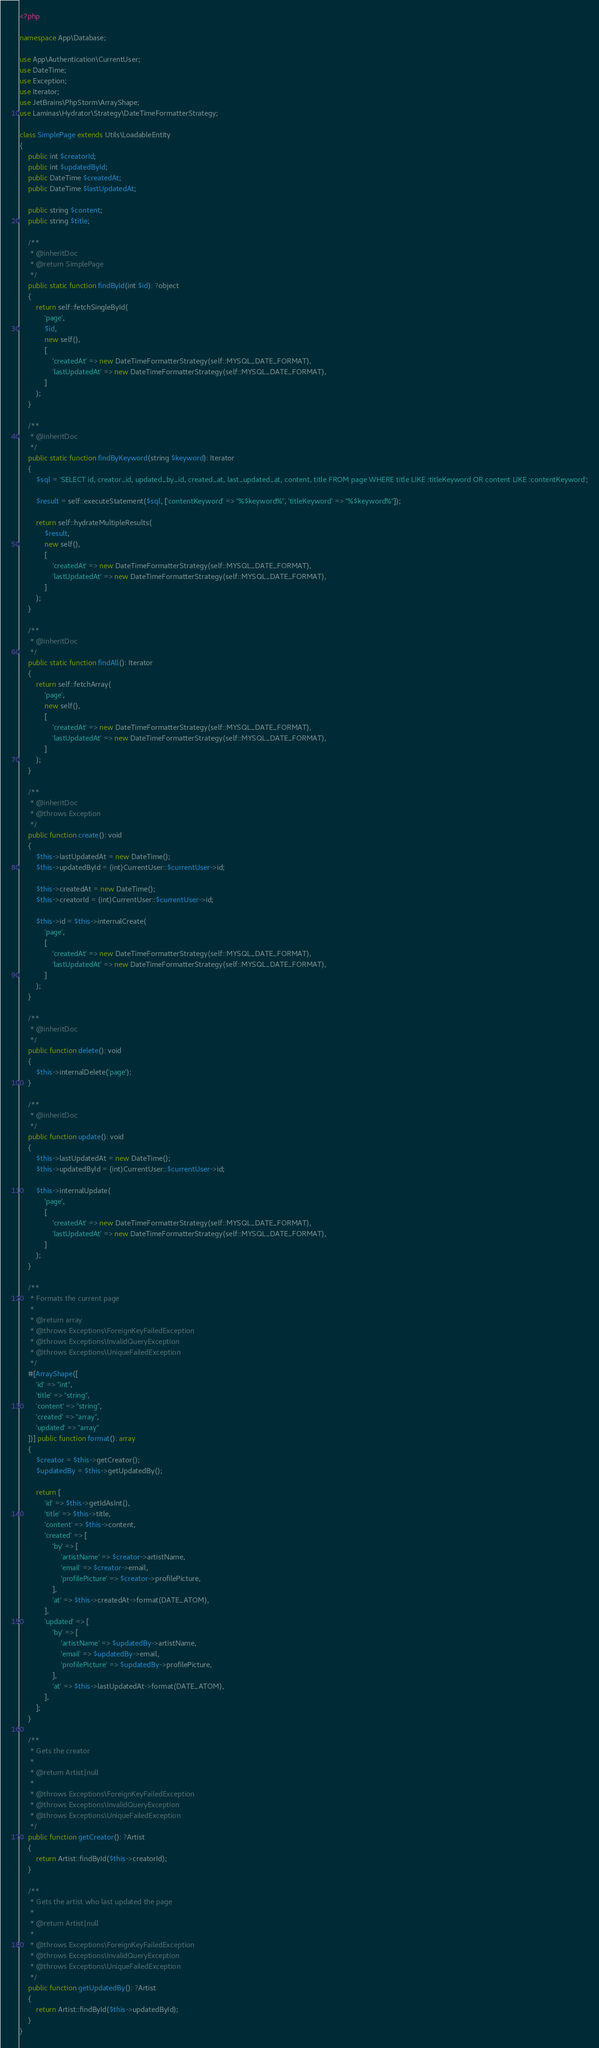<code> <loc_0><loc_0><loc_500><loc_500><_PHP_><?php

namespace App\Database;

use App\Authentication\CurrentUser;
use DateTime;
use Exception;
use Iterator;
use JetBrains\PhpStorm\ArrayShape;
use Laminas\Hydrator\Strategy\DateTimeFormatterStrategy;

class SimplePage extends Utils\LoadableEntity
{
    public int $creatorId;
    public int $updatedById;
    public DateTime $createdAt;
    public DateTime $lastUpdatedAt;

    public string $content;
    public string $title;

    /**
     * @inheritDoc
     * @return SimplePage
     */
    public static function findById(int $id): ?object
    {
        return self::fetchSingleById(
            'page',
            $id,
            new self(),
            [
                'createdAt' => new DateTimeFormatterStrategy(self::MYSQL_DATE_FORMAT),
                'lastUpdatedAt' => new DateTimeFormatterStrategy(self::MYSQL_DATE_FORMAT),
            ]
        );
    }

    /**
     * @inheritDoc
     */
    public static function findByKeyword(string $keyword): Iterator
    {
        $sql = 'SELECT id, creator_id, updated_by_id, created_at, last_updated_at, content, title FROM page WHERE title LIKE :titleKeyword OR content LIKE :contentKeyword';

        $result = self::executeStatement($sql, ['contentKeyword' => "%$keyword%", 'titleKeyword' => "%$keyword%"]);

        return self::hydrateMultipleResults(
            $result,
            new self(),
            [
                'createdAt' => new DateTimeFormatterStrategy(self::MYSQL_DATE_FORMAT),
                'lastUpdatedAt' => new DateTimeFormatterStrategy(self::MYSQL_DATE_FORMAT),
            ]
        );
    }

    /**
     * @inheritDoc
     */
    public static function findAll(): Iterator
    {
        return self::fetchArray(
            'page',
            new self(),
            [
                'createdAt' => new DateTimeFormatterStrategy(self::MYSQL_DATE_FORMAT),
                'lastUpdatedAt' => new DateTimeFormatterStrategy(self::MYSQL_DATE_FORMAT),
            ]
        );
    }

    /**
     * @inheritDoc
     * @throws Exception
     */
    public function create(): void
    {
        $this->lastUpdatedAt = new DateTime();
        $this->updatedById = (int)CurrentUser::$currentUser->id;

        $this->createdAt = new DateTime();
        $this->creatorId = (int)CurrentUser::$currentUser->id;

        $this->id = $this->internalCreate(
            'page',
            [
                'createdAt' => new DateTimeFormatterStrategy(self::MYSQL_DATE_FORMAT),
                'lastUpdatedAt' => new DateTimeFormatterStrategy(self::MYSQL_DATE_FORMAT),
            ]
        );
    }

    /**
     * @inheritDoc
     */
    public function delete(): void
    {
        $this->internalDelete('page');
    }

    /**
     * @inheritDoc
     */
    public function update(): void
    {
        $this->lastUpdatedAt = new DateTime();
        $this->updatedById = (int)CurrentUser::$currentUser->id;

        $this->internalUpdate(
            'page',
            [
                'createdAt' => new DateTimeFormatterStrategy(self::MYSQL_DATE_FORMAT),
                'lastUpdatedAt' => new DateTimeFormatterStrategy(self::MYSQL_DATE_FORMAT),
            ]
        );
    }

    /**
     * Formats the current page
     *
     * @return array
     * @throws Exceptions\ForeignKeyFailedException
     * @throws Exceptions\InvalidQueryException
     * @throws Exceptions\UniqueFailedException
     */
    #[ArrayShape([
        'id' => "int",
        'title' => "string",
        'content' => "string",
        'created' => "array",
        'updated' => "array"
    ])] public function format(): array
    {
        $creator = $this->getCreator();
        $updatedBy = $this->getUpdatedBy();

        return [
            'id' => $this->getIdAsInt(),
            'title' => $this->title,
            'content' => $this->content,
            'created' => [
                'by' => [
                    'artistName' => $creator->artistName,
                    'email' => $creator->email,
                    'profilePicture' => $creator->profilePicture,
                ],
                'at' => $this->createdAt->format(DATE_ATOM),
            ],
            'updated' => [
                'by' => [
                    'artistName' => $updatedBy->artistName,
                    'email' => $updatedBy->email,
                    'profilePicture' => $updatedBy->profilePicture,
                ],
                'at' => $this->lastUpdatedAt->format(DATE_ATOM),
            ],
        ];
    }

    /**
     * Gets the creator
     *
     * @return Artist|null
     *
     * @throws Exceptions\ForeignKeyFailedException
     * @throws Exceptions\InvalidQueryException
     * @throws Exceptions\UniqueFailedException
     */
    public function getCreator(): ?Artist
    {
        return Artist::findById($this->creatorId);
    }

    /**
     * Gets the artist who last updated the page
     *
     * @return Artist|null
     *
     * @throws Exceptions\ForeignKeyFailedException
     * @throws Exceptions\InvalidQueryException
     * @throws Exceptions\UniqueFailedException
     */
    public function getUpdatedBy(): ?Artist
    {
        return Artist::findById($this->updatedById);
    }
}</code> 